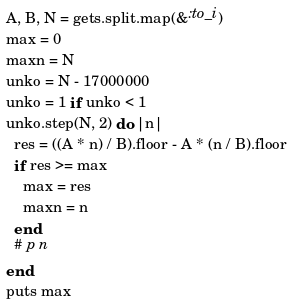Convert code to text. <code><loc_0><loc_0><loc_500><loc_500><_Ruby_>A, B, N = gets.split.map(&:to_i)
max = 0
maxn = N
unko = N - 17000000
unko = 1 if unko < 1
unko.step(N, 2) do |n|
  res = ((A * n) / B).floor - A * (n / B).floor
  if res >= max
    max = res
    maxn = n
  end
  # p n
end
puts max
</code> 